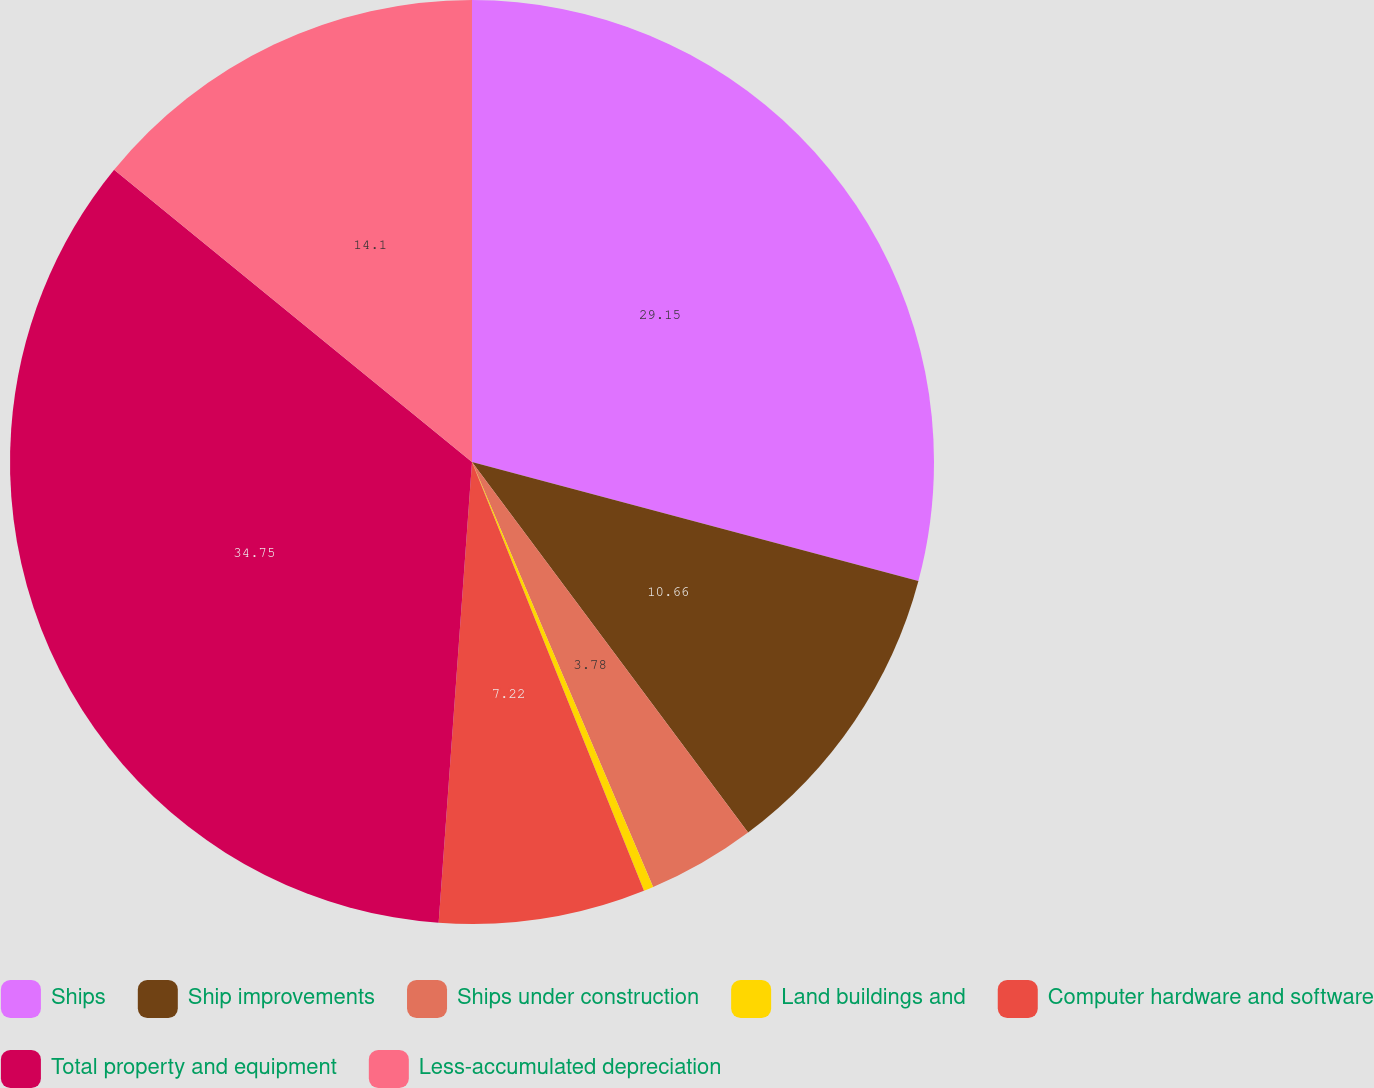Convert chart. <chart><loc_0><loc_0><loc_500><loc_500><pie_chart><fcel>Ships<fcel>Ship improvements<fcel>Ships under construction<fcel>Land buildings and<fcel>Computer hardware and software<fcel>Total property and equipment<fcel>Less-accumulated depreciation<nl><fcel>29.14%<fcel>10.66%<fcel>3.78%<fcel>0.34%<fcel>7.22%<fcel>34.74%<fcel>14.1%<nl></chart> 